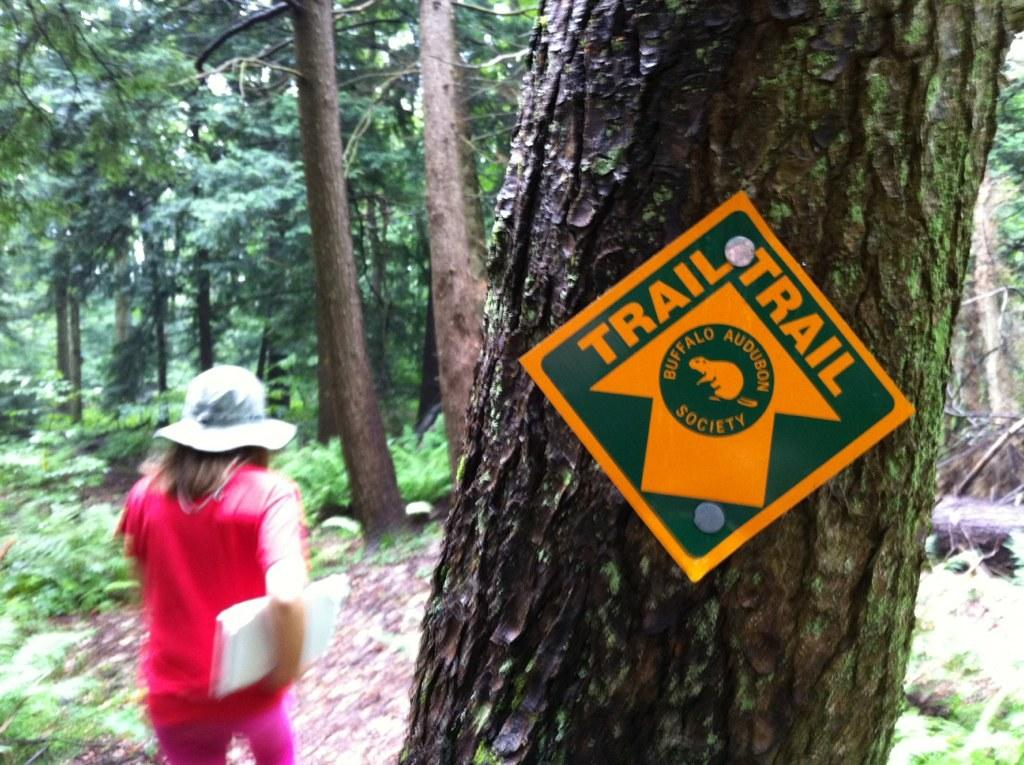What is on the tree trunk in the image? There is a board on a tree trunk in the image. What can be seen on the left side of the image? A person is standing on the left side of the image. What is the person wearing on their head? The person is wearing a hat. What color is the dress the person is wearing? The person is wearing a pink dress. What is the person holding in the image? The person is holding an object. What type of environment is visible in the background of the image? There are trees visible in the background of the image. What type of beast can be seen running through the trees in the image? There is no beast visible in the image; it only features a person standing on the left side of the tree trunk with a board. How many cars are parked near the trees in the image? There are no cars present in the image; it only features a person standing on the left side of the tree trunk with a board. 